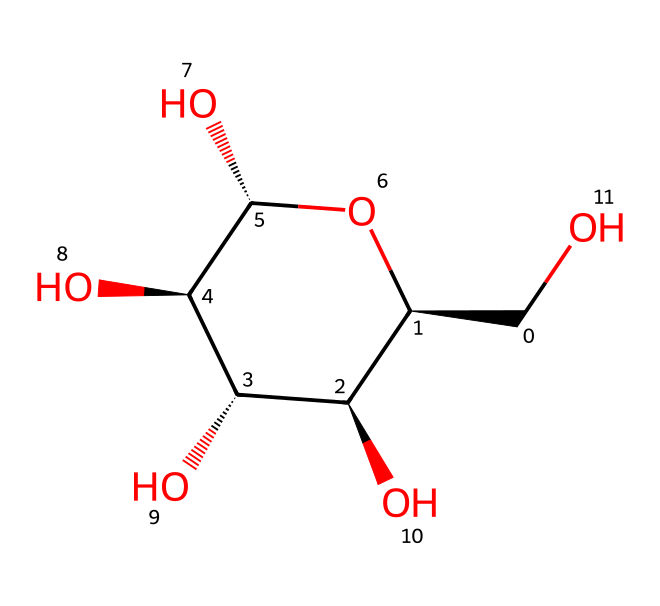What is the primary sugar unit in this structure? This chemical is a polysaccharide made up of repeating glucose units. The structure clearly indicates the presence of hydroxyl (-OH) groups attached to the carbon atoms typical of glucose.
Answer: glucose How many carbon atoms are present in the structure? By examining the SMILES representation, we can count the number of carbon atoms; there are six carbon atoms visible in the ring structure as well as one carbon in the side chain. Therefore, the total number is seven.
Answer: seven What type of bond connects the glucose units? The visual inspection of the structure shows that the bonds between the glucose units are glycosidic bonds, which specifically form between the hydroxyl groups of each glucose unit.
Answer: glycosidic What functional groups are primarily present in this molecule? This compound exhibits multiple hydroxyl (-OH) groups, which characterize its solubility in water and contribute to its carbohydrate classification. The multiple hydroxyl groups indicate it is a sugar alcohol.
Answer: hydroxyl groups How does this structure contribute to its use in makeup removers? The numerous hydroxyl groups contribute to the polar nature of the molecule, enhancing its ability to dissolve in water and bind to oils and pigments on the skin, making it effective as a makeup remover.
Answer: polar nature What is the total number of hydroxyl groups in the structure? Each glucose unit contributes a hydroxyl group, and considering the structure, there are five hydroxyl groups attached to the carbon skeleton of the compound, indicating its hydrophilic nature.
Answer: five 